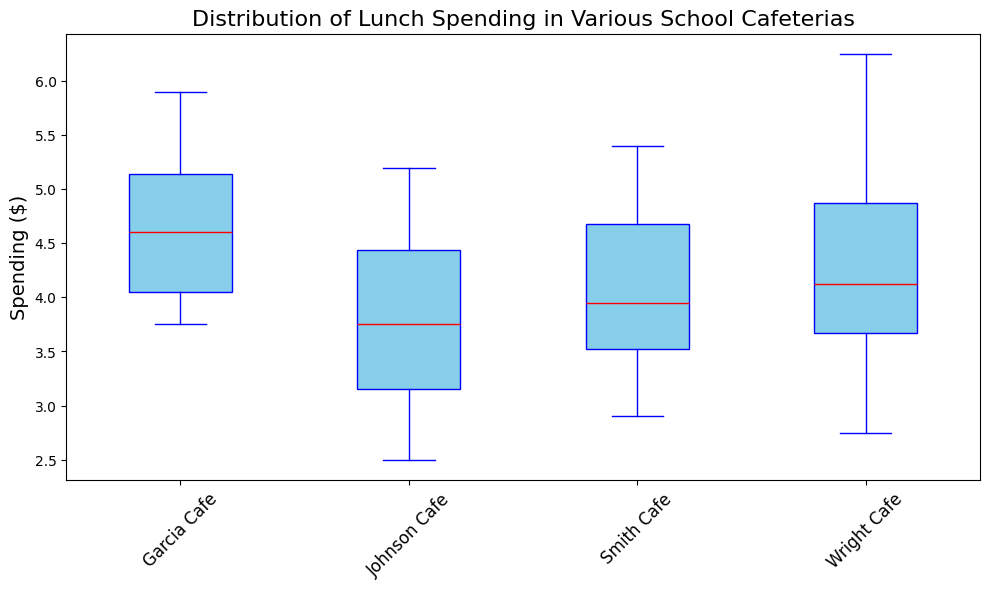What is the median spending at Wright Cafe? To find the median, we need to look at the middle value of the data set when it is ordered. In the box plot, the median is represented by the red line.
Answer: The median at Wright Cafe is $4.25 How does the range of spending at Johnson Cafe compare to that at Smith Cafe? To compare the range, we need to look at the difference between the highest and lowest values (whiskers). So for each cafeteria, identify the minimum and maximum values and subtract the minimum from the maximum.
Answer: Johnson Cafe has a range of $2.70, and Smith Cafe has a range of $2.50 Which cafeteria has the highest median spending? From the box plot, identify the cafeteria with the highest red line (median).
Answer: Garcia Cafe Does Wright Cafe have any outliers in its spending data? Outliers would be indicated by points outside the whiskers of the box plot. Look for any individual points outside the end lines of the whisker.
Answer: No, Wright Cafe does not have outliers Which cafeteria had the smallest interquartile range (IQR) for spending? The IQR is the range between the first quartile (bottom of the box) and the third quartile (top of the box). Compare the heights of the boxes for each cafeteria.
Answer: Smith Cafe What can you tell about the average spending in Garcia Cafe compared to the other cafeterias? While the box plot doesn't show the average, we can infer the general level based on the median and the spread of values. Garcia Cafe has the highest median spending, indicating generally higher spending compared to other cafeterias.
Answer: Garcia Cafe has a higher average spending compared to the others Which cafeteria has the widest spread of spending data? Identify the cafeteria with the longest whiskers, indicating the most spread-out spending.
Answer: Wright Cafe Is there any cafeteria where the maximum spending is more than $6? Check the top whisker or any outliers above the $6 mark for each cafeteria.
Answer: Wright Cafe What is the relative position of the median spending of Johnson Cafe compared to that of Smith Cafe? Compare the heights of the red lines (medians) to see which is higher or lower.
Answer: The median of Johnson Cafe is slightly less than that of Smith Cafe How do the spending distributions of Wright Cafe and Garcia Cafe differ? Look at the spread, medians, and any outliers to compare how spending varies.
Answer: Garcia Cafe has a higher median and less spread, while Wright Cafe has a lower median and more spread 